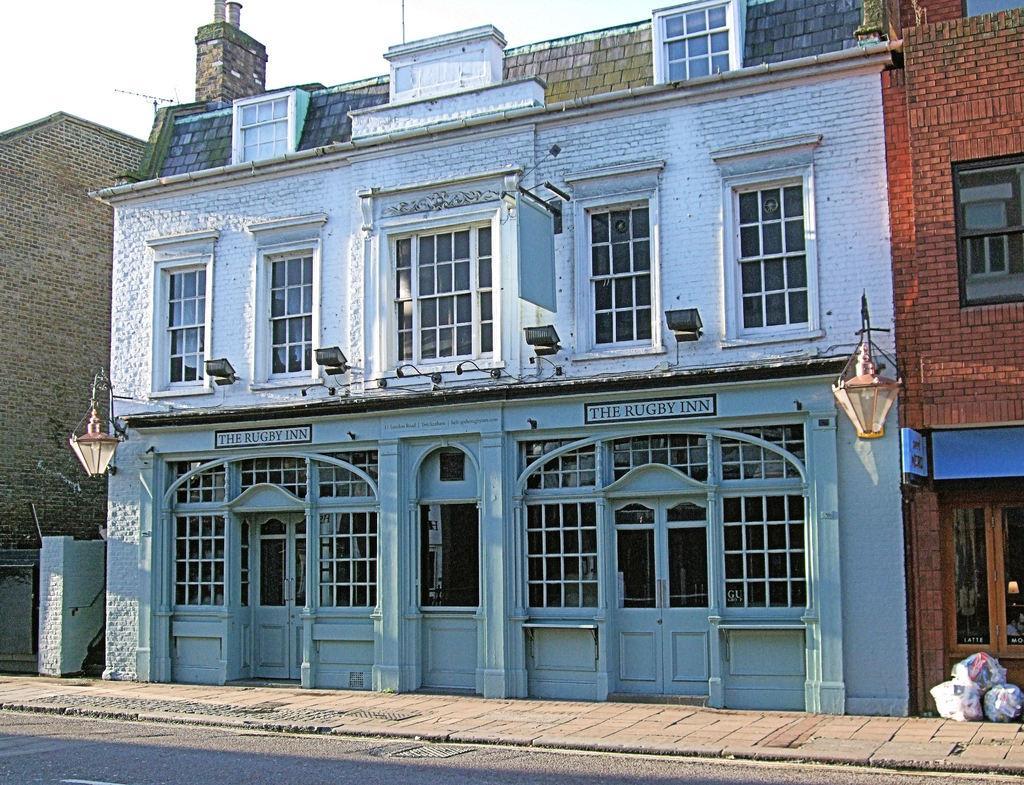Could you give a brief overview of what you see in this image? In this image, we can see some buildings and there are some white color doors and there are some windows, at the top there is a sky. 